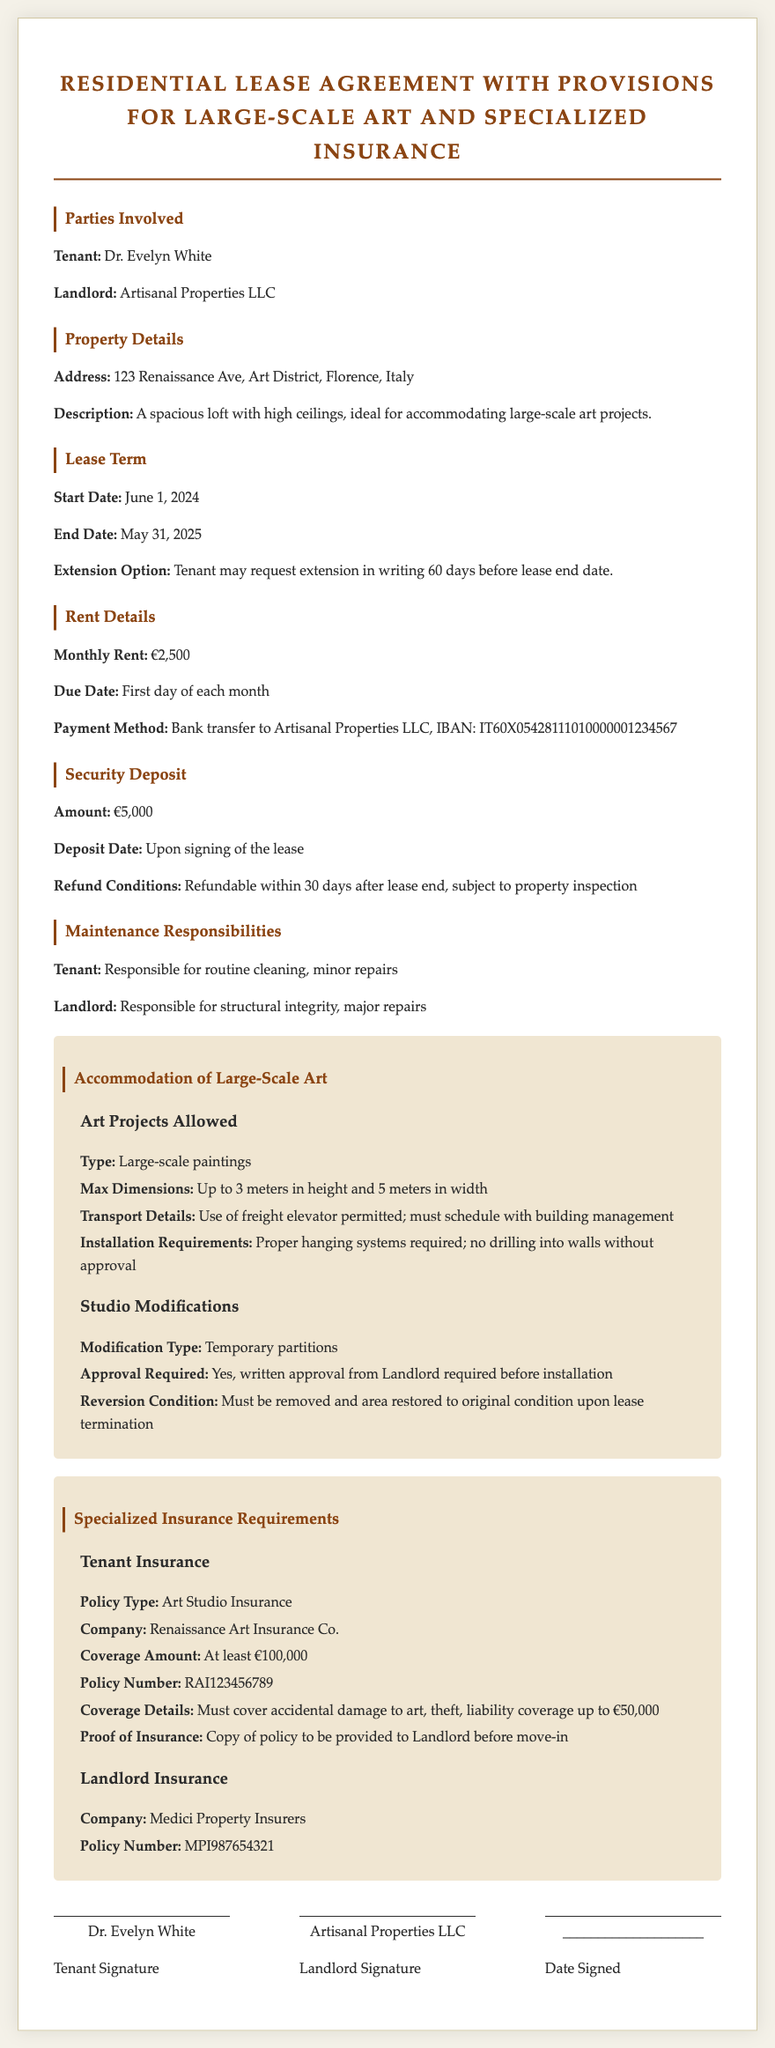What is the name of the tenant? The name of the tenant can be found in the "Parties Involved" section of the document.
Answer: Dr. Evelyn White What is the address of the property? The address of the property is specified under the "Property Details" section.
Answer: 123 Renaissance Ave, Art District, Florence, Italy What is the monthly rent amount? The monthly rent is provided in the "Rent Details" section of the document.
Answer: €2,500 What is the maximum height allowed for large-scale art? This detail is found in the "Accommodation of Large-Scale Art" section.
Answer: Up to 3 meters What is the required insurance coverage amount for tenant insurance? This information is detailed in the "Tenant Insurance" subsection under "Specialized Insurance Requirements."
Answer: At least €100,000 What is the security deposit amount? The security deposit amount is stated in the "Security Deposit" section.
Answer: €5,000 Which company provides landlord insurance? This can be found in the "Landlord Insurance" subsection under "Specialized Insurance Requirements."
Answer: Medici Property Insurers When does the lease term start? The start date of the lease term is specified in the "Lease Term" section.
Answer: June 1, 2024 What modifications require written approval from the landlord? This refers to modifications listed in the "Studio Modifications" subsection in "Accommodation of Large-Scale Art."
Answer: Temporary partitions 